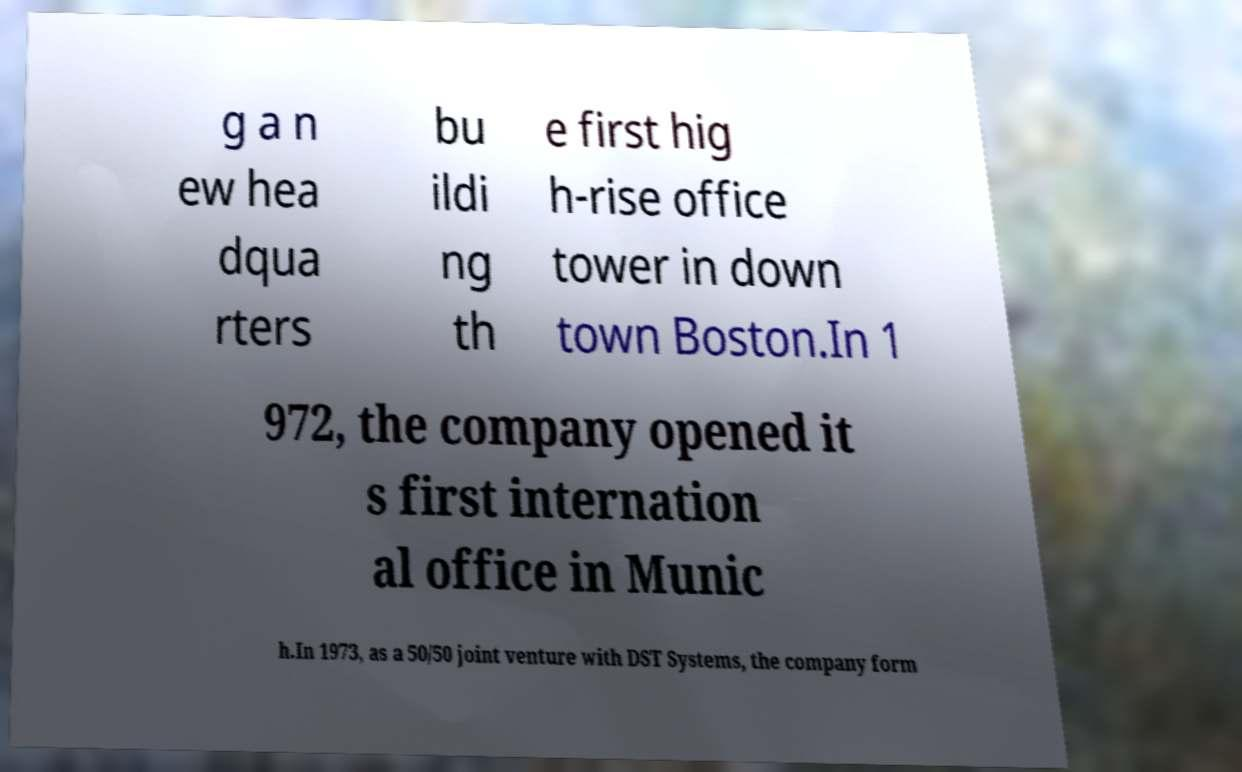Please read and relay the text visible in this image. What does it say? g a n ew hea dqua rters bu ildi ng th e first hig h-rise office tower in down town Boston.In 1 972, the company opened it s first internation al office in Munic h.In 1973, as a 50/50 joint venture with DST Systems, the company form 